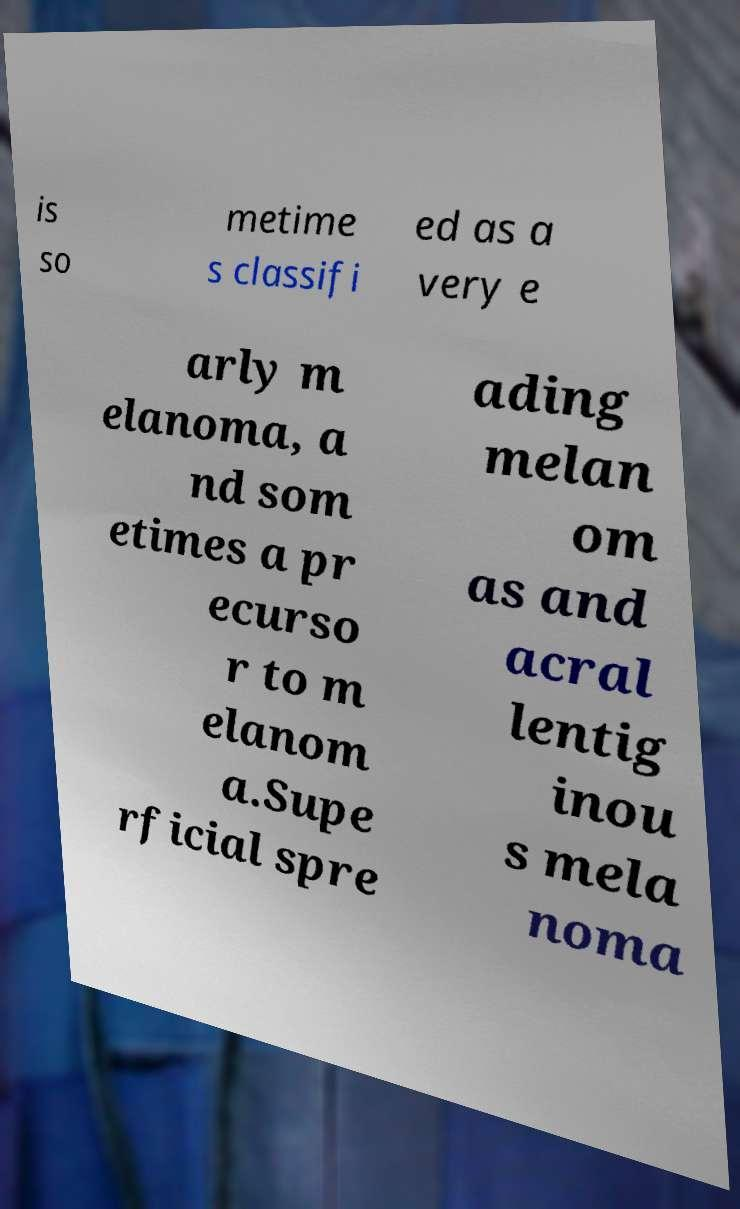Can you read and provide the text displayed in the image?This photo seems to have some interesting text. Can you extract and type it out for me? is so metime s classifi ed as a very e arly m elanoma, a nd som etimes a pr ecurso r to m elanom a.Supe rficial spre ading melan om as and acral lentig inou s mela noma 